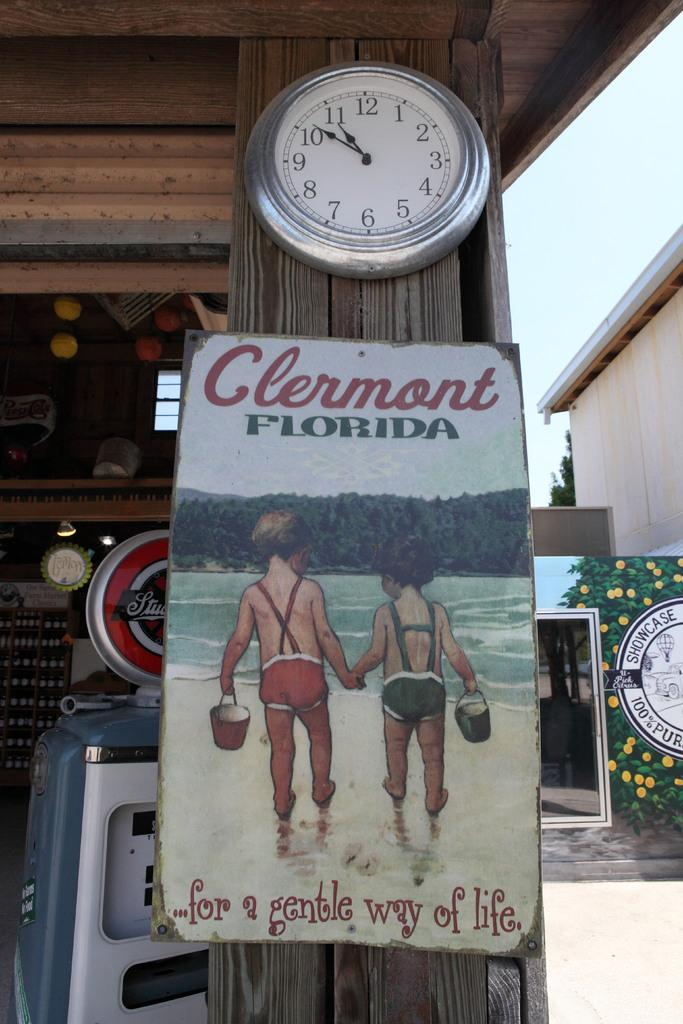Provide a one-sentence caption for the provided image. A sign with two boys holding hands that says Clermont Florida. 